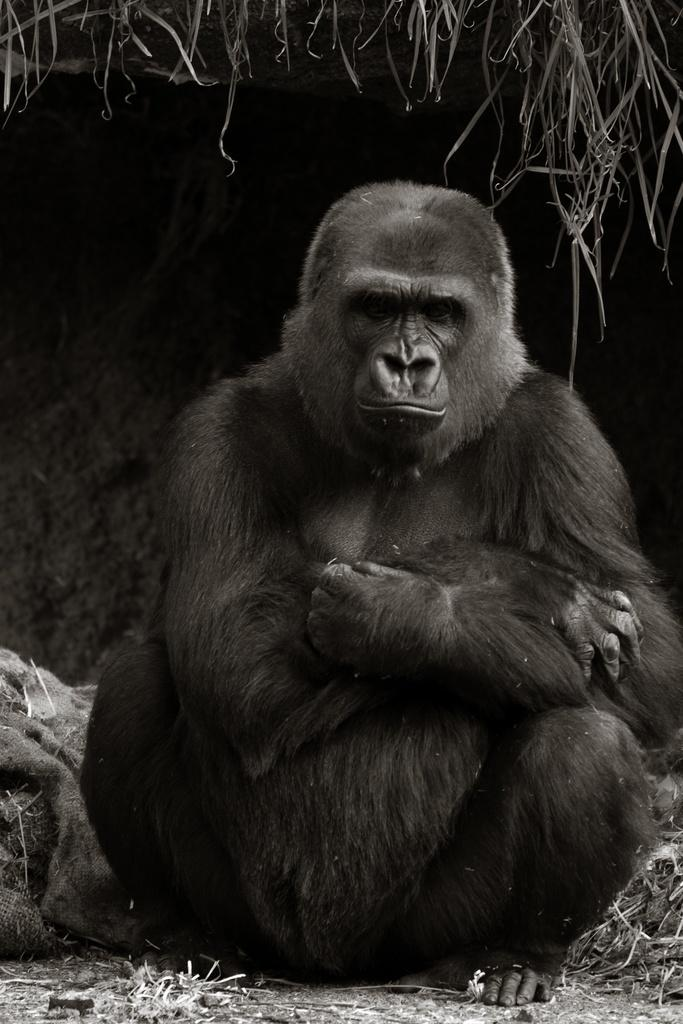What type of animal is in the image? There is a gorilla in the image. What is the gorilla doing in the image? The gorilla is sitting on the ground. What type of cave can be seen in the background of the image? There is no cave present in the image; it features a gorilla sitting on the ground. What type of attraction is the gorilla a part of in the image? The image does not provide any information about the gorilla being a part of an attraction. 